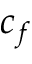Convert formula to latex. <formula><loc_0><loc_0><loc_500><loc_500>c _ { f }</formula> 